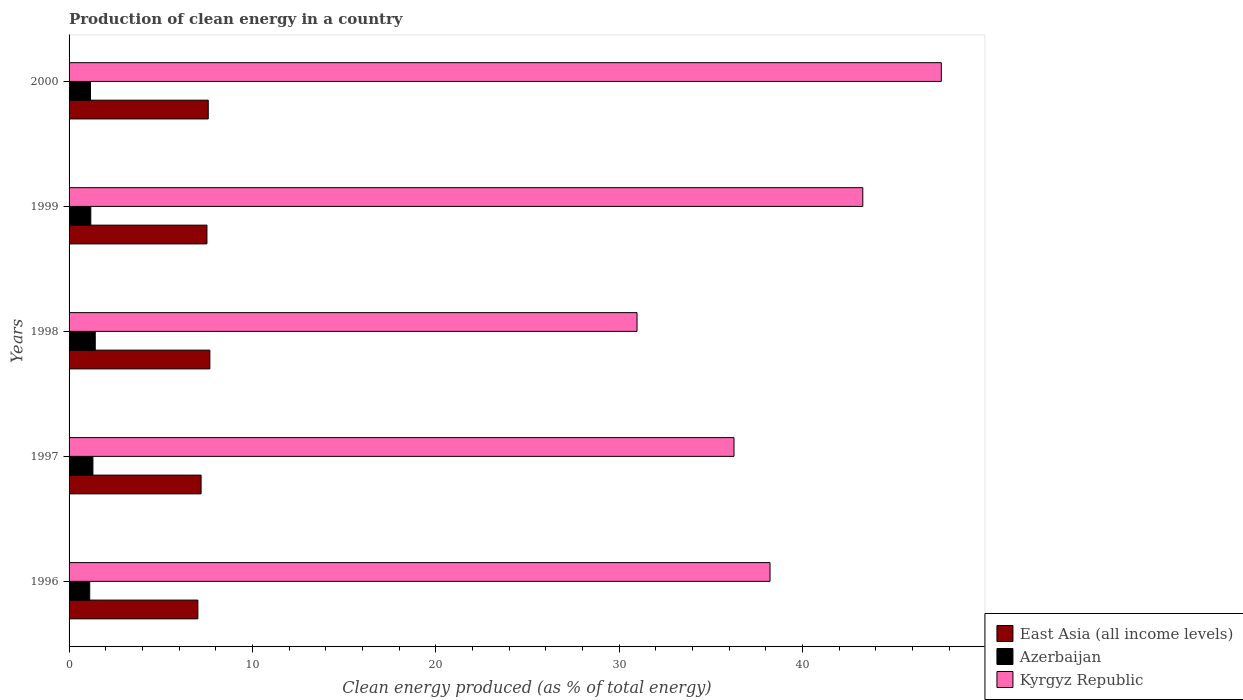How many different coloured bars are there?
Your answer should be very brief. 3. How many groups of bars are there?
Make the answer very short. 5. Are the number of bars per tick equal to the number of legend labels?
Provide a short and direct response. Yes. How many bars are there on the 5th tick from the top?
Make the answer very short. 3. How many bars are there on the 2nd tick from the bottom?
Offer a terse response. 3. What is the label of the 5th group of bars from the top?
Give a very brief answer. 1996. In how many cases, is the number of bars for a given year not equal to the number of legend labels?
Ensure brevity in your answer.  0. What is the percentage of clean energy produced in East Asia (all income levels) in 1999?
Your answer should be very brief. 7.52. Across all years, what is the maximum percentage of clean energy produced in East Asia (all income levels)?
Offer a very short reply. 7.68. Across all years, what is the minimum percentage of clean energy produced in Kyrgyz Republic?
Offer a terse response. 30.97. In which year was the percentage of clean energy produced in East Asia (all income levels) maximum?
Ensure brevity in your answer.  1998. What is the total percentage of clean energy produced in Azerbaijan in the graph?
Give a very brief answer. 6.21. What is the difference between the percentage of clean energy produced in Kyrgyz Republic in 1996 and that in 1997?
Your answer should be very brief. 1.96. What is the difference between the percentage of clean energy produced in East Asia (all income levels) in 1997 and the percentage of clean energy produced in Kyrgyz Republic in 1999?
Keep it short and to the point. -36.08. What is the average percentage of clean energy produced in Azerbaijan per year?
Ensure brevity in your answer.  1.24. In the year 2000, what is the difference between the percentage of clean energy produced in Kyrgyz Republic and percentage of clean energy produced in East Asia (all income levels)?
Your response must be concise. 39.98. In how many years, is the percentage of clean energy produced in East Asia (all income levels) greater than 8 %?
Keep it short and to the point. 0. What is the ratio of the percentage of clean energy produced in Kyrgyz Republic in 1997 to that in 1998?
Give a very brief answer. 1.17. What is the difference between the highest and the second highest percentage of clean energy produced in East Asia (all income levels)?
Provide a short and direct response. 0.09. What is the difference between the highest and the lowest percentage of clean energy produced in Kyrgyz Republic?
Your answer should be compact. 16.59. Is the sum of the percentage of clean energy produced in Kyrgyz Republic in 1998 and 2000 greater than the maximum percentage of clean energy produced in Azerbaijan across all years?
Provide a short and direct response. Yes. What does the 2nd bar from the top in 1997 represents?
Provide a succinct answer. Azerbaijan. What does the 3rd bar from the bottom in 1997 represents?
Provide a short and direct response. Kyrgyz Republic. Is it the case that in every year, the sum of the percentage of clean energy produced in East Asia (all income levels) and percentage of clean energy produced in Kyrgyz Republic is greater than the percentage of clean energy produced in Azerbaijan?
Provide a short and direct response. Yes. Are all the bars in the graph horizontal?
Make the answer very short. Yes. Does the graph contain any zero values?
Your answer should be compact. No. Does the graph contain grids?
Provide a short and direct response. No. What is the title of the graph?
Your response must be concise. Production of clean energy in a country. Does "Cameroon" appear as one of the legend labels in the graph?
Provide a succinct answer. No. What is the label or title of the X-axis?
Make the answer very short. Clean energy produced (as % of total energy). What is the label or title of the Y-axis?
Offer a terse response. Years. What is the Clean energy produced (as % of total energy) of East Asia (all income levels) in 1996?
Keep it short and to the point. 7.02. What is the Clean energy produced (as % of total energy) in Azerbaijan in 1996?
Give a very brief answer. 1.13. What is the Clean energy produced (as % of total energy) of Kyrgyz Republic in 1996?
Your answer should be very brief. 38.22. What is the Clean energy produced (as % of total energy) of East Asia (all income levels) in 1997?
Offer a terse response. 7.2. What is the Clean energy produced (as % of total energy) in Azerbaijan in 1997?
Your answer should be compact. 1.3. What is the Clean energy produced (as % of total energy) in Kyrgyz Republic in 1997?
Keep it short and to the point. 36.26. What is the Clean energy produced (as % of total energy) in East Asia (all income levels) in 1998?
Give a very brief answer. 7.68. What is the Clean energy produced (as % of total energy) of Azerbaijan in 1998?
Keep it short and to the point. 1.43. What is the Clean energy produced (as % of total energy) in Kyrgyz Republic in 1998?
Your answer should be compact. 30.97. What is the Clean energy produced (as % of total energy) of East Asia (all income levels) in 1999?
Offer a very short reply. 7.52. What is the Clean energy produced (as % of total energy) in Azerbaijan in 1999?
Offer a very short reply. 1.19. What is the Clean energy produced (as % of total energy) of Kyrgyz Republic in 1999?
Your answer should be compact. 43.28. What is the Clean energy produced (as % of total energy) in East Asia (all income levels) in 2000?
Your response must be concise. 7.59. What is the Clean energy produced (as % of total energy) in Azerbaijan in 2000?
Your answer should be very brief. 1.17. What is the Clean energy produced (as % of total energy) in Kyrgyz Republic in 2000?
Offer a terse response. 47.57. Across all years, what is the maximum Clean energy produced (as % of total energy) of East Asia (all income levels)?
Offer a terse response. 7.68. Across all years, what is the maximum Clean energy produced (as % of total energy) in Azerbaijan?
Provide a short and direct response. 1.43. Across all years, what is the maximum Clean energy produced (as % of total energy) in Kyrgyz Republic?
Your answer should be very brief. 47.57. Across all years, what is the minimum Clean energy produced (as % of total energy) of East Asia (all income levels)?
Your answer should be very brief. 7.02. Across all years, what is the minimum Clean energy produced (as % of total energy) of Azerbaijan?
Your answer should be compact. 1.13. Across all years, what is the minimum Clean energy produced (as % of total energy) of Kyrgyz Republic?
Ensure brevity in your answer.  30.97. What is the total Clean energy produced (as % of total energy) of East Asia (all income levels) in the graph?
Offer a terse response. 37.01. What is the total Clean energy produced (as % of total energy) in Azerbaijan in the graph?
Ensure brevity in your answer.  6.21. What is the total Clean energy produced (as % of total energy) in Kyrgyz Republic in the graph?
Make the answer very short. 196.31. What is the difference between the Clean energy produced (as % of total energy) in East Asia (all income levels) in 1996 and that in 1997?
Your answer should be very brief. -0.17. What is the difference between the Clean energy produced (as % of total energy) in Azerbaijan in 1996 and that in 1997?
Keep it short and to the point. -0.17. What is the difference between the Clean energy produced (as % of total energy) of Kyrgyz Republic in 1996 and that in 1997?
Ensure brevity in your answer.  1.96. What is the difference between the Clean energy produced (as % of total energy) of East Asia (all income levels) in 1996 and that in 1998?
Your answer should be very brief. -0.65. What is the difference between the Clean energy produced (as % of total energy) in Azerbaijan in 1996 and that in 1998?
Ensure brevity in your answer.  -0.3. What is the difference between the Clean energy produced (as % of total energy) of Kyrgyz Republic in 1996 and that in 1998?
Provide a short and direct response. 7.25. What is the difference between the Clean energy produced (as % of total energy) of East Asia (all income levels) in 1996 and that in 1999?
Give a very brief answer. -0.49. What is the difference between the Clean energy produced (as % of total energy) of Azerbaijan in 1996 and that in 1999?
Offer a very short reply. -0.06. What is the difference between the Clean energy produced (as % of total energy) in Kyrgyz Republic in 1996 and that in 1999?
Offer a terse response. -5.06. What is the difference between the Clean energy produced (as % of total energy) of East Asia (all income levels) in 1996 and that in 2000?
Give a very brief answer. -0.57. What is the difference between the Clean energy produced (as % of total energy) in Azerbaijan in 1996 and that in 2000?
Offer a very short reply. -0.04. What is the difference between the Clean energy produced (as % of total energy) of Kyrgyz Republic in 1996 and that in 2000?
Offer a very short reply. -9.34. What is the difference between the Clean energy produced (as % of total energy) of East Asia (all income levels) in 1997 and that in 1998?
Offer a very short reply. -0.48. What is the difference between the Clean energy produced (as % of total energy) of Azerbaijan in 1997 and that in 1998?
Your response must be concise. -0.13. What is the difference between the Clean energy produced (as % of total energy) of Kyrgyz Republic in 1997 and that in 1998?
Keep it short and to the point. 5.29. What is the difference between the Clean energy produced (as % of total energy) in East Asia (all income levels) in 1997 and that in 1999?
Provide a succinct answer. -0.32. What is the difference between the Clean energy produced (as % of total energy) of Azerbaijan in 1997 and that in 1999?
Your answer should be compact. 0.12. What is the difference between the Clean energy produced (as % of total energy) of Kyrgyz Republic in 1997 and that in 1999?
Your answer should be compact. -7.02. What is the difference between the Clean energy produced (as % of total energy) in East Asia (all income levels) in 1997 and that in 2000?
Provide a short and direct response. -0.39. What is the difference between the Clean energy produced (as % of total energy) in Azerbaijan in 1997 and that in 2000?
Offer a terse response. 0.13. What is the difference between the Clean energy produced (as % of total energy) in Kyrgyz Republic in 1997 and that in 2000?
Your response must be concise. -11.31. What is the difference between the Clean energy produced (as % of total energy) in East Asia (all income levels) in 1998 and that in 1999?
Offer a terse response. 0.16. What is the difference between the Clean energy produced (as % of total energy) of Azerbaijan in 1998 and that in 1999?
Your answer should be very brief. 0.24. What is the difference between the Clean energy produced (as % of total energy) in Kyrgyz Republic in 1998 and that in 1999?
Keep it short and to the point. -12.31. What is the difference between the Clean energy produced (as % of total energy) in East Asia (all income levels) in 1998 and that in 2000?
Provide a short and direct response. 0.09. What is the difference between the Clean energy produced (as % of total energy) of Azerbaijan in 1998 and that in 2000?
Give a very brief answer. 0.26. What is the difference between the Clean energy produced (as % of total energy) in Kyrgyz Republic in 1998 and that in 2000?
Your response must be concise. -16.59. What is the difference between the Clean energy produced (as % of total energy) of East Asia (all income levels) in 1999 and that in 2000?
Keep it short and to the point. -0.07. What is the difference between the Clean energy produced (as % of total energy) of Azerbaijan in 1999 and that in 2000?
Your answer should be very brief. 0.02. What is the difference between the Clean energy produced (as % of total energy) in Kyrgyz Republic in 1999 and that in 2000?
Your answer should be very brief. -4.28. What is the difference between the Clean energy produced (as % of total energy) of East Asia (all income levels) in 1996 and the Clean energy produced (as % of total energy) of Azerbaijan in 1997?
Your answer should be very brief. 5.72. What is the difference between the Clean energy produced (as % of total energy) in East Asia (all income levels) in 1996 and the Clean energy produced (as % of total energy) in Kyrgyz Republic in 1997?
Offer a terse response. -29.24. What is the difference between the Clean energy produced (as % of total energy) in Azerbaijan in 1996 and the Clean energy produced (as % of total energy) in Kyrgyz Republic in 1997?
Offer a terse response. -35.13. What is the difference between the Clean energy produced (as % of total energy) of East Asia (all income levels) in 1996 and the Clean energy produced (as % of total energy) of Azerbaijan in 1998?
Your answer should be very brief. 5.6. What is the difference between the Clean energy produced (as % of total energy) in East Asia (all income levels) in 1996 and the Clean energy produced (as % of total energy) in Kyrgyz Republic in 1998?
Keep it short and to the point. -23.95. What is the difference between the Clean energy produced (as % of total energy) in Azerbaijan in 1996 and the Clean energy produced (as % of total energy) in Kyrgyz Republic in 1998?
Offer a very short reply. -29.85. What is the difference between the Clean energy produced (as % of total energy) in East Asia (all income levels) in 1996 and the Clean energy produced (as % of total energy) in Azerbaijan in 1999?
Ensure brevity in your answer.  5.84. What is the difference between the Clean energy produced (as % of total energy) of East Asia (all income levels) in 1996 and the Clean energy produced (as % of total energy) of Kyrgyz Republic in 1999?
Your answer should be very brief. -36.26. What is the difference between the Clean energy produced (as % of total energy) in Azerbaijan in 1996 and the Clean energy produced (as % of total energy) in Kyrgyz Republic in 1999?
Ensure brevity in your answer.  -42.16. What is the difference between the Clean energy produced (as % of total energy) in East Asia (all income levels) in 1996 and the Clean energy produced (as % of total energy) in Azerbaijan in 2000?
Make the answer very short. 5.86. What is the difference between the Clean energy produced (as % of total energy) in East Asia (all income levels) in 1996 and the Clean energy produced (as % of total energy) in Kyrgyz Republic in 2000?
Provide a succinct answer. -40.54. What is the difference between the Clean energy produced (as % of total energy) in Azerbaijan in 1996 and the Clean energy produced (as % of total energy) in Kyrgyz Republic in 2000?
Ensure brevity in your answer.  -46.44. What is the difference between the Clean energy produced (as % of total energy) of East Asia (all income levels) in 1997 and the Clean energy produced (as % of total energy) of Azerbaijan in 1998?
Ensure brevity in your answer.  5.77. What is the difference between the Clean energy produced (as % of total energy) of East Asia (all income levels) in 1997 and the Clean energy produced (as % of total energy) of Kyrgyz Republic in 1998?
Keep it short and to the point. -23.77. What is the difference between the Clean energy produced (as % of total energy) of Azerbaijan in 1997 and the Clean energy produced (as % of total energy) of Kyrgyz Republic in 1998?
Keep it short and to the point. -29.67. What is the difference between the Clean energy produced (as % of total energy) in East Asia (all income levels) in 1997 and the Clean energy produced (as % of total energy) in Azerbaijan in 1999?
Make the answer very short. 6.01. What is the difference between the Clean energy produced (as % of total energy) of East Asia (all income levels) in 1997 and the Clean energy produced (as % of total energy) of Kyrgyz Republic in 1999?
Make the answer very short. -36.08. What is the difference between the Clean energy produced (as % of total energy) of Azerbaijan in 1997 and the Clean energy produced (as % of total energy) of Kyrgyz Republic in 1999?
Offer a terse response. -41.98. What is the difference between the Clean energy produced (as % of total energy) in East Asia (all income levels) in 1997 and the Clean energy produced (as % of total energy) in Azerbaijan in 2000?
Offer a terse response. 6.03. What is the difference between the Clean energy produced (as % of total energy) of East Asia (all income levels) in 1997 and the Clean energy produced (as % of total energy) of Kyrgyz Republic in 2000?
Make the answer very short. -40.37. What is the difference between the Clean energy produced (as % of total energy) of Azerbaijan in 1997 and the Clean energy produced (as % of total energy) of Kyrgyz Republic in 2000?
Your answer should be very brief. -46.27. What is the difference between the Clean energy produced (as % of total energy) in East Asia (all income levels) in 1998 and the Clean energy produced (as % of total energy) in Azerbaijan in 1999?
Your answer should be compact. 6.49. What is the difference between the Clean energy produced (as % of total energy) in East Asia (all income levels) in 1998 and the Clean energy produced (as % of total energy) in Kyrgyz Republic in 1999?
Provide a succinct answer. -35.61. What is the difference between the Clean energy produced (as % of total energy) of Azerbaijan in 1998 and the Clean energy produced (as % of total energy) of Kyrgyz Republic in 1999?
Give a very brief answer. -41.86. What is the difference between the Clean energy produced (as % of total energy) in East Asia (all income levels) in 1998 and the Clean energy produced (as % of total energy) in Azerbaijan in 2000?
Ensure brevity in your answer.  6.51. What is the difference between the Clean energy produced (as % of total energy) of East Asia (all income levels) in 1998 and the Clean energy produced (as % of total energy) of Kyrgyz Republic in 2000?
Offer a terse response. -39.89. What is the difference between the Clean energy produced (as % of total energy) of Azerbaijan in 1998 and the Clean energy produced (as % of total energy) of Kyrgyz Republic in 2000?
Provide a short and direct response. -46.14. What is the difference between the Clean energy produced (as % of total energy) in East Asia (all income levels) in 1999 and the Clean energy produced (as % of total energy) in Azerbaijan in 2000?
Your answer should be very brief. 6.35. What is the difference between the Clean energy produced (as % of total energy) of East Asia (all income levels) in 1999 and the Clean energy produced (as % of total energy) of Kyrgyz Republic in 2000?
Offer a terse response. -40.05. What is the difference between the Clean energy produced (as % of total energy) in Azerbaijan in 1999 and the Clean energy produced (as % of total energy) in Kyrgyz Republic in 2000?
Provide a succinct answer. -46.38. What is the average Clean energy produced (as % of total energy) of East Asia (all income levels) per year?
Make the answer very short. 7.4. What is the average Clean energy produced (as % of total energy) in Azerbaijan per year?
Ensure brevity in your answer.  1.24. What is the average Clean energy produced (as % of total energy) of Kyrgyz Republic per year?
Offer a terse response. 39.26. In the year 1996, what is the difference between the Clean energy produced (as % of total energy) in East Asia (all income levels) and Clean energy produced (as % of total energy) in Azerbaijan?
Keep it short and to the point. 5.9. In the year 1996, what is the difference between the Clean energy produced (as % of total energy) of East Asia (all income levels) and Clean energy produced (as % of total energy) of Kyrgyz Republic?
Offer a very short reply. -31.2. In the year 1996, what is the difference between the Clean energy produced (as % of total energy) in Azerbaijan and Clean energy produced (as % of total energy) in Kyrgyz Republic?
Offer a terse response. -37.1. In the year 1997, what is the difference between the Clean energy produced (as % of total energy) of East Asia (all income levels) and Clean energy produced (as % of total energy) of Azerbaijan?
Your answer should be compact. 5.9. In the year 1997, what is the difference between the Clean energy produced (as % of total energy) of East Asia (all income levels) and Clean energy produced (as % of total energy) of Kyrgyz Republic?
Provide a short and direct response. -29.06. In the year 1997, what is the difference between the Clean energy produced (as % of total energy) of Azerbaijan and Clean energy produced (as % of total energy) of Kyrgyz Republic?
Give a very brief answer. -34.96. In the year 1998, what is the difference between the Clean energy produced (as % of total energy) in East Asia (all income levels) and Clean energy produced (as % of total energy) in Azerbaijan?
Ensure brevity in your answer.  6.25. In the year 1998, what is the difference between the Clean energy produced (as % of total energy) in East Asia (all income levels) and Clean energy produced (as % of total energy) in Kyrgyz Republic?
Your answer should be compact. -23.29. In the year 1998, what is the difference between the Clean energy produced (as % of total energy) of Azerbaijan and Clean energy produced (as % of total energy) of Kyrgyz Republic?
Your answer should be compact. -29.54. In the year 1999, what is the difference between the Clean energy produced (as % of total energy) in East Asia (all income levels) and Clean energy produced (as % of total energy) in Azerbaijan?
Provide a short and direct response. 6.33. In the year 1999, what is the difference between the Clean energy produced (as % of total energy) in East Asia (all income levels) and Clean energy produced (as % of total energy) in Kyrgyz Republic?
Offer a terse response. -35.77. In the year 1999, what is the difference between the Clean energy produced (as % of total energy) in Azerbaijan and Clean energy produced (as % of total energy) in Kyrgyz Republic?
Make the answer very short. -42.1. In the year 2000, what is the difference between the Clean energy produced (as % of total energy) of East Asia (all income levels) and Clean energy produced (as % of total energy) of Azerbaijan?
Provide a short and direct response. 6.42. In the year 2000, what is the difference between the Clean energy produced (as % of total energy) in East Asia (all income levels) and Clean energy produced (as % of total energy) in Kyrgyz Republic?
Your response must be concise. -39.98. In the year 2000, what is the difference between the Clean energy produced (as % of total energy) of Azerbaijan and Clean energy produced (as % of total energy) of Kyrgyz Republic?
Offer a very short reply. -46.4. What is the ratio of the Clean energy produced (as % of total energy) of East Asia (all income levels) in 1996 to that in 1997?
Your answer should be compact. 0.98. What is the ratio of the Clean energy produced (as % of total energy) of Azerbaijan in 1996 to that in 1997?
Provide a short and direct response. 0.87. What is the ratio of the Clean energy produced (as % of total energy) of Kyrgyz Republic in 1996 to that in 1997?
Your answer should be compact. 1.05. What is the ratio of the Clean energy produced (as % of total energy) of East Asia (all income levels) in 1996 to that in 1998?
Your answer should be compact. 0.91. What is the ratio of the Clean energy produced (as % of total energy) of Azerbaijan in 1996 to that in 1998?
Make the answer very short. 0.79. What is the ratio of the Clean energy produced (as % of total energy) of Kyrgyz Republic in 1996 to that in 1998?
Your response must be concise. 1.23. What is the ratio of the Clean energy produced (as % of total energy) of East Asia (all income levels) in 1996 to that in 1999?
Give a very brief answer. 0.93. What is the ratio of the Clean energy produced (as % of total energy) of Azerbaijan in 1996 to that in 1999?
Ensure brevity in your answer.  0.95. What is the ratio of the Clean energy produced (as % of total energy) of Kyrgyz Republic in 1996 to that in 1999?
Your answer should be compact. 0.88. What is the ratio of the Clean energy produced (as % of total energy) of East Asia (all income levels) in 1996 to that in 2000?
Offer a very short reply. 0.93. What is the ratio of the Clean energy produced (as % of total energy) in Azerbaijan in 1996 to that in 2000?
Keep it short and to the point. 0.96. What is the ratio of the Clean energy produced (as % of total energy) of Kyrgyz Republic in 1996 to that in 2000?
Provide a succinct answer. 0.8. What is the ratio of the Clean energy produced (as % of total energy) of East Asia (all income levels) in 1997 to that in 1998?
Make the answer very short. 0.94. What is the ratio of the Clean energy produced (as % of total energy) of Azerbaijan in 1997 to that in 1998?
Make the answer very short. 0.91. What is the ratio of the Clean energy produced (as % of total energy) of Kyrgyz Republic in 1997 to that in 1998?
Keep it short and to the point. 1.17. What is the ratio of the Clean energy produced (as % of total energy) of East Asia (all income levels) in 1997 to that in 1999?
Provide a short and direct response. 0.96. What is the ratio of the Clean energy produced (as % of total energy) of Azerbaijan in 1997 to that in 1999?
Your answer should be very brief. 1.1. What is the ratio of the Clean energy produced (as % of total energy) of Kyrgyz Republic in 1997 to that in 1999?
Your answer should be very brief. 0.84. What is the ratio of the Clean energy produced (as % of total energy) of East Asia (all income levels) in 1997 to that in 2000?
Your answer should be very brief. 0.95. What is the ratio of the Clean energy produced (as % of total energy) in Azerbaijan in 1997 to that in 2000?
Give a very brief answer. 1.11. What is the ratio of the Clean energy produced (as % of total energy) of Kyrgyz Republic in 1997 to that in 2000?
Your response must be concise. 0.76. What is the ratio of the Clean energy produced (as % of total energy) of East Asia (all income levels) in 1998 to that in 1999?
Offer a terse response. 1.02. What is the ratio of the Clean energy produced (as % of total energy) in Azerbaijan in 1998 to that in 1999?
Provide a short and direct response. 1.2. What is the ratio of the Clean energy produced (as % of total energy) in Kyrgyz Republic in 1998 to that in 1999?
Your answer should be compact. 0.72. What is the ratio of the Clean energy produced (as % of total energy) of East Asia (all income levels) in 1998 to that in 2000?
Provide a succinct answer. 1.01. What is the ratio of the Clean energy produced (as % of total energy) in Azerbaijan in 1998 to that in 2000?
Provide a succinct answer. 1.22. What is the ratio of the Clean energy produced (as % of total energy) in Kyrgyz Republic in 1998 to that in 2000?
Your answer should be very brief. 0.65. What is the ratio of the Clean energy produced (as % of total energy) of East Asia (all income levels) in 1999 to that in 2000?
Your answer should be compact. 0.99. What is the ratio of the Clean energy produced (as % of total energy) of Azerbaijan in 1999 to that in 2000?
Make the answer very short. 1.01. What is the ratio of the Clean energy produced (as % of total energy) of Kyrgyz Republic in 1999 to that in 2000?
Make the answer very short. 0.91. What is the difference between the highest and the second highest Clean energy produced (as % of total energy) of East Asia (all income levels)?
Ensure brevity in your answer.  0.09. What is the difference between the highest and the second highest Clean energy produced (as % of total energy) of Azerbaijan?
Offer a very short reply. 0.13. What is the difference between the highest and the second highest Clean energy produced (as % of total energy) of Kyrgyz Republic?
Offer a very short reply. 4.28. What is the difference between the highest and the lowest Clean energy produced (as % of total energy) in East Asia (all income levels)?
Your response must be concise. 0.65. What is the difference between the highest and the lowest Clean energy produced (as % of total energy) of Azerbaijan?
Your answer should be compact. 0.3. What is the difference between the highest and the lowest Clean energy produced (as % of total energy) in Kyrgyz Republic?
Ensure brevity in your answer.  16.59. 